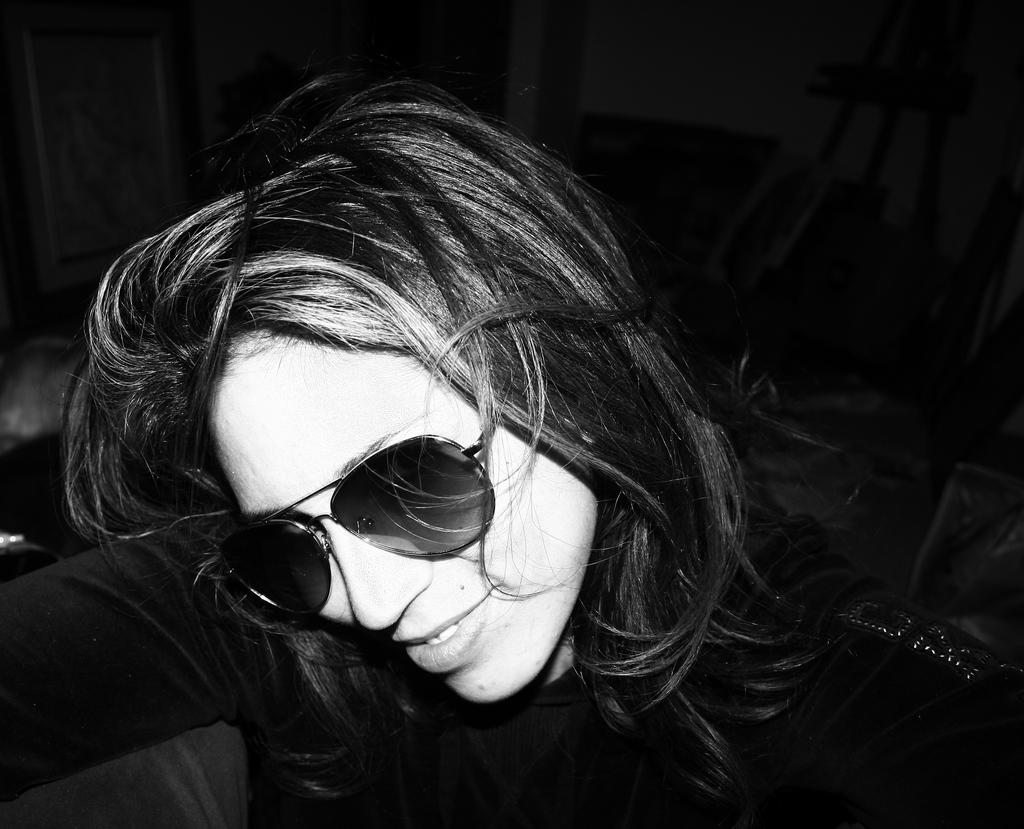What is the color scheme of the image? The image is black and white. Who is present in the image? There is a woman in the image. What is the woman wearing in the image? The woman is wearing spectacles in the image. How many cows are visible in the image? There are no cows present in the image; it features a woman wearing spectacles in a black and white setting. 